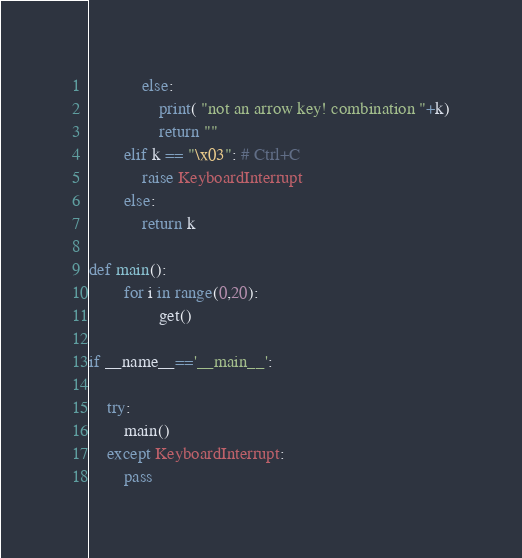Convert code to text. <code><loc_0><loc_0><loc_500><loc_500><_Python_>			else:
				print( "not an arrow key! combination "+k)
				return ""
		elif k == "\x03": # Ctrl+C
			raise KeyboardInterrupt
		else:
			return k

def main():
		for i in range(0,20):
				get()

if __name__=='__main__':

	try:
		main()
	except KeyboardInterrupt:
		pass
</code> 